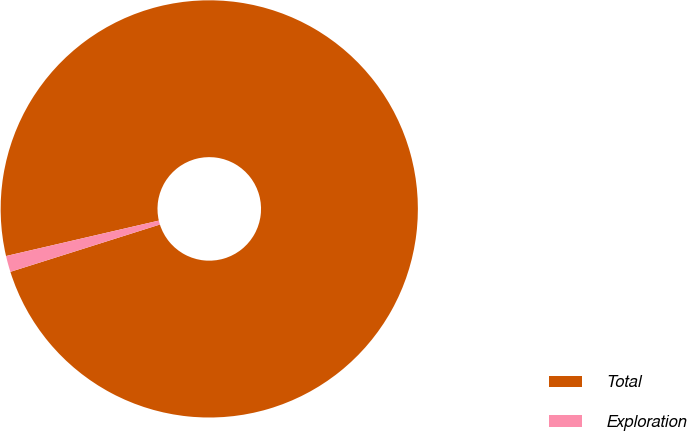Convert chart. <chart><loc_0><loc_0><loc_500><loc_500><pie_chart><fcel>Total<fcel>Exploration<nl><fcel>98.75%<fcel>1.25%<nl></chart> 